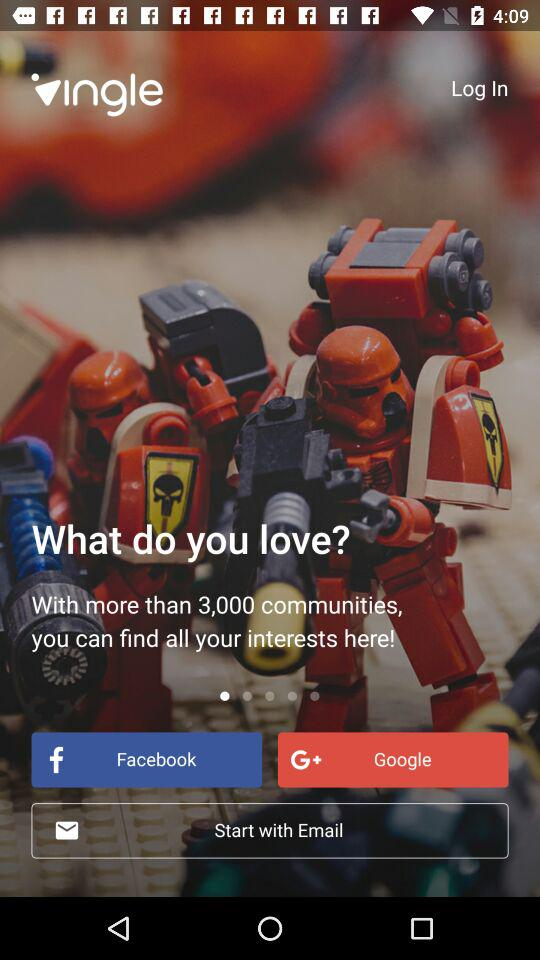Which application can be used to log in? The applications that can be used to log in are "Facebook" and "Google". 